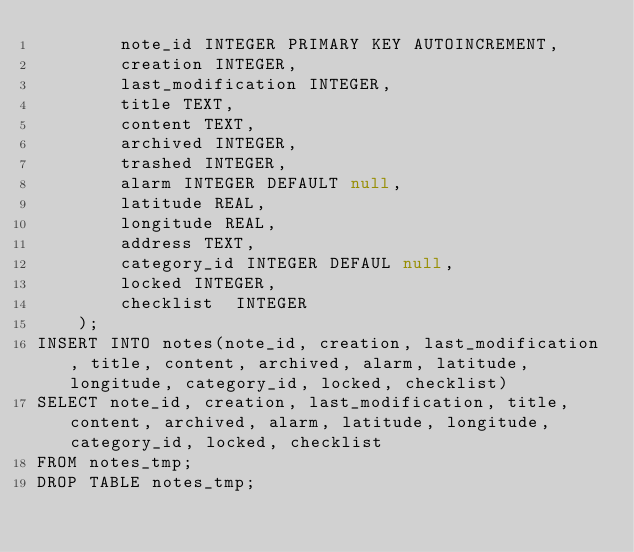<code> <loc_0><loc_0><loc_500><loc_500><_SQL_>		note_id INTEGER PRIMARY KEY AUTOINCREMENT,
		creation INTEGER,
		last_modification INTEGER,
		title TEXT,
		content TEXT,
		archived INTEGER,
		trashed INTEGER,
		alarm INTEGER DEFAULT null,
		latitude REAL,
		longitude REAL,
		address TEXT,
		category_id INTEGER DEFAUL null,
		locked INTEGER,  
		checklist  INTEGER   
	);
INSERT INTO notes(note_id, creation, last_modification, title, content, archived, alarm, latitude, longitude, category_id, locked, checklist)
SELECT note_id, creation, last_modification, title, content, archived, alarm, latitude, longitude, category_id, locked, checklist
FROM notes_tmp;
DROP TABLE notes_tmp; 
</code> 